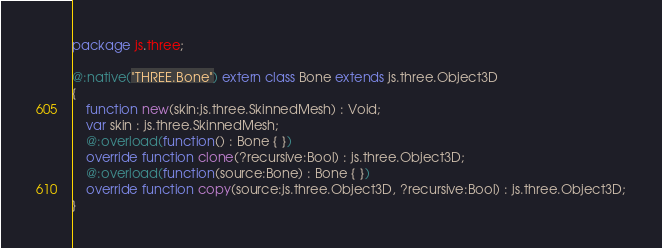Convert code to text. <code><loc_0><loc_0><loc_500><loc_500><_Haxe_>package js.three;

@:native("THREE.Bone") extern class Bone extends js.three.Object3D
{
	function new(skin:js.three.SkinnedMesh) : Void;
	var skin : js.three.SkinnedMesh;
	@:overload(function() : Bone { })
	override function clone(?recursive:Bool) : js.three.Object3D;
	@:overload(function(source:Bone) : Bone { })
	override function copy(source:js.three.Object3D, ?recursive:Bool) : js.three.Object3D;
}</code> 